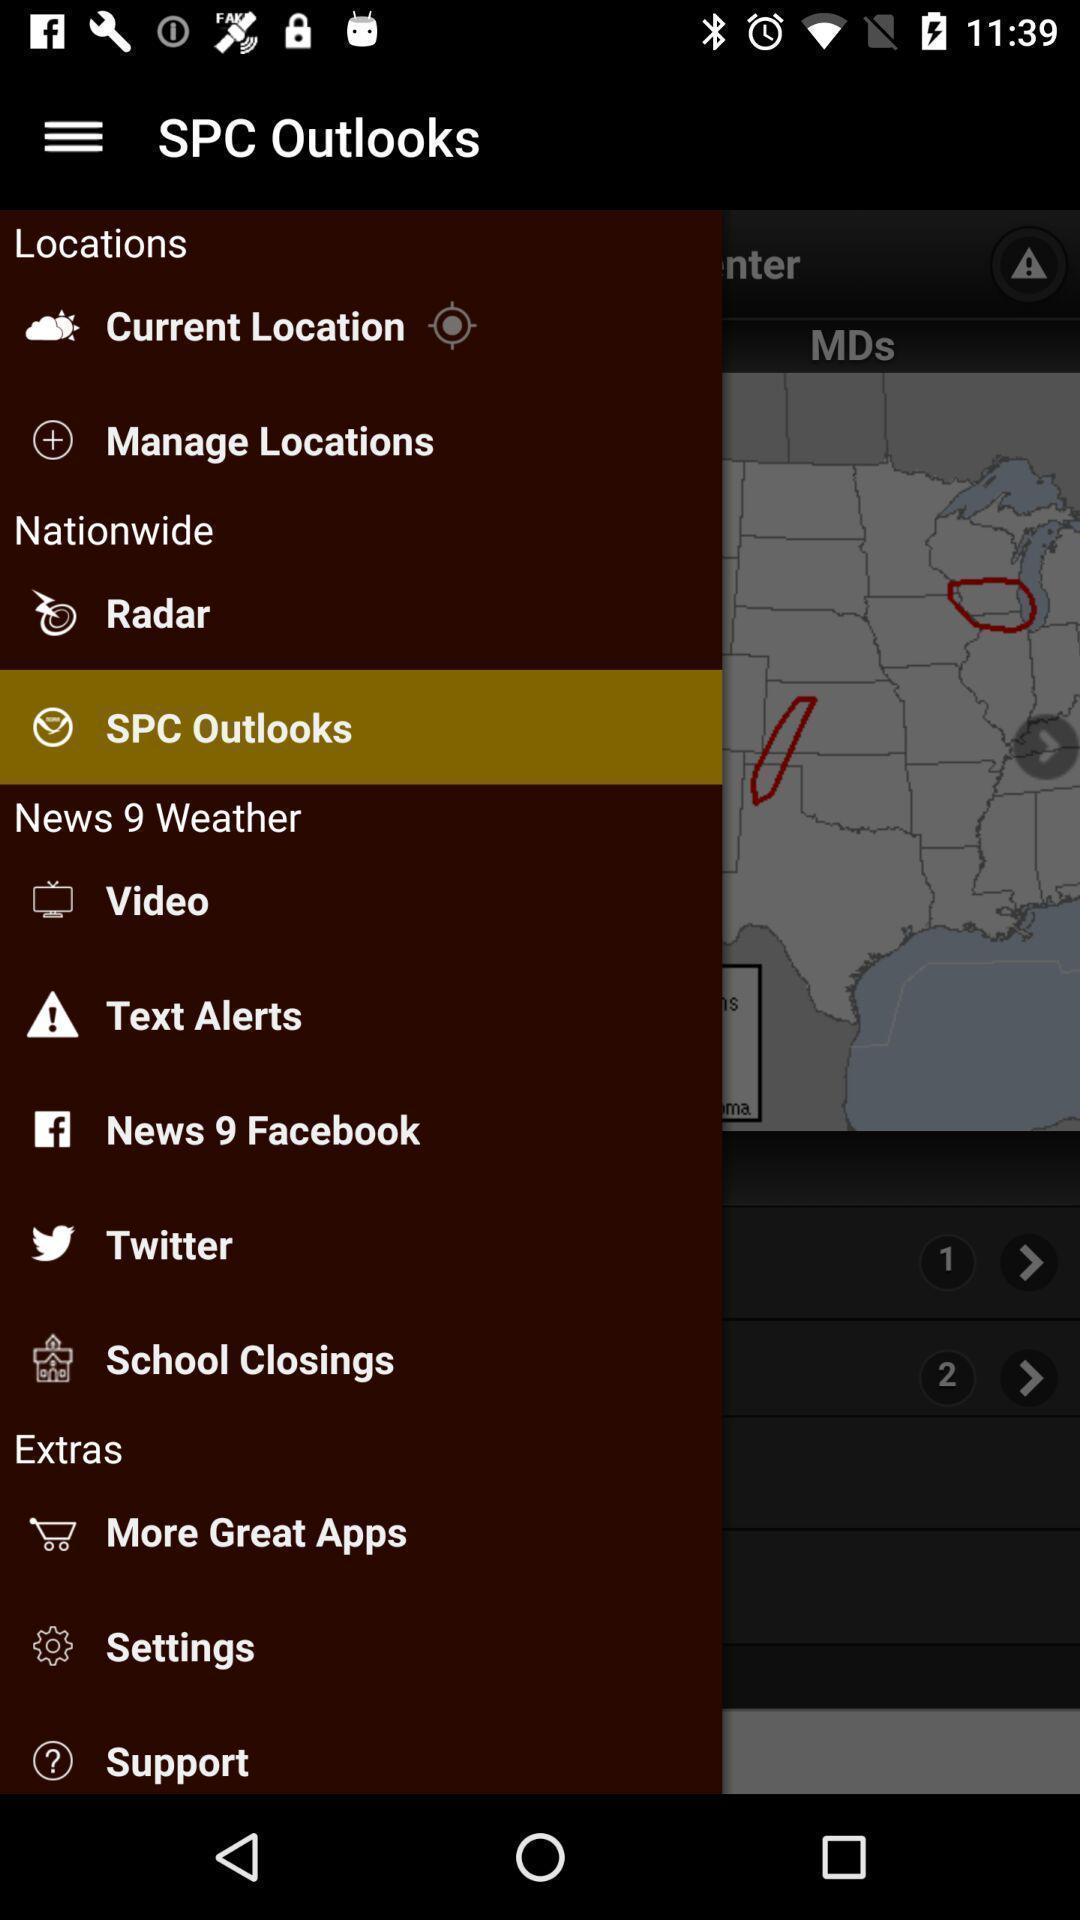What can you discern from this picture? Pop up displaying different menu options. 